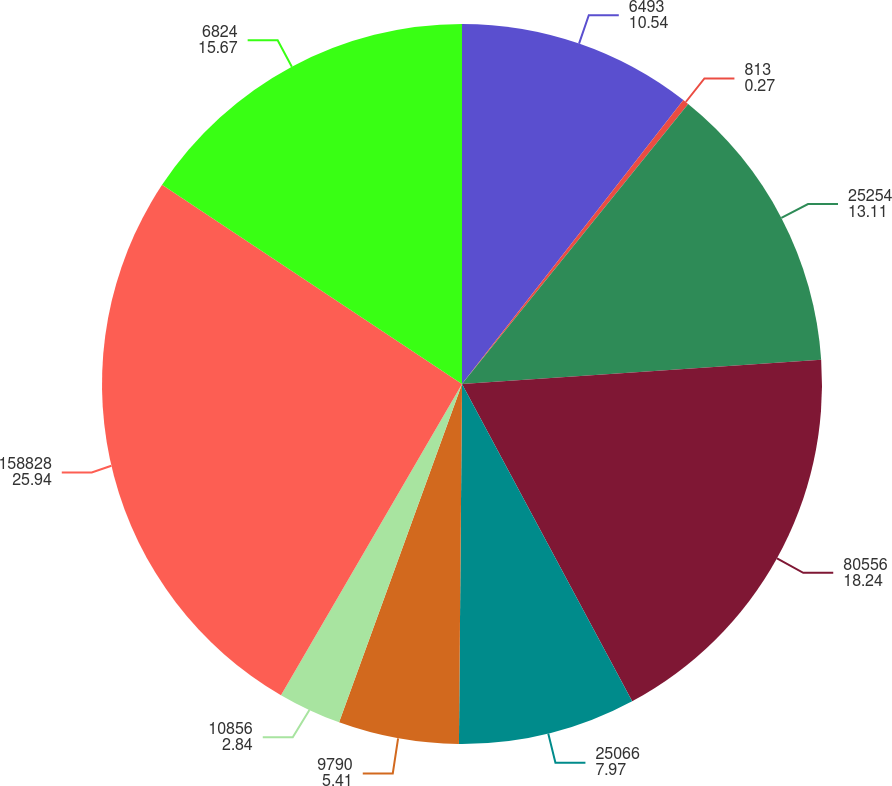Convert chart to OTSL. <chart><loc_0><loc_0><loc_500><loc_500><pie_chart><fcel>6493<fcel>813<fcel>25254<fcel>80556<fcel>25066<fcel>9790<fcel>10856<fcel>158828<fcel>6824<nl><fcel>10.54%<fcel>0.27%<fcel>13.11%<fcel>18.24%<fcel>7.97%<fcel>5.41%<fcel>2.84%<fcel>25.94%<fcel>15.67%<nl></chart> 